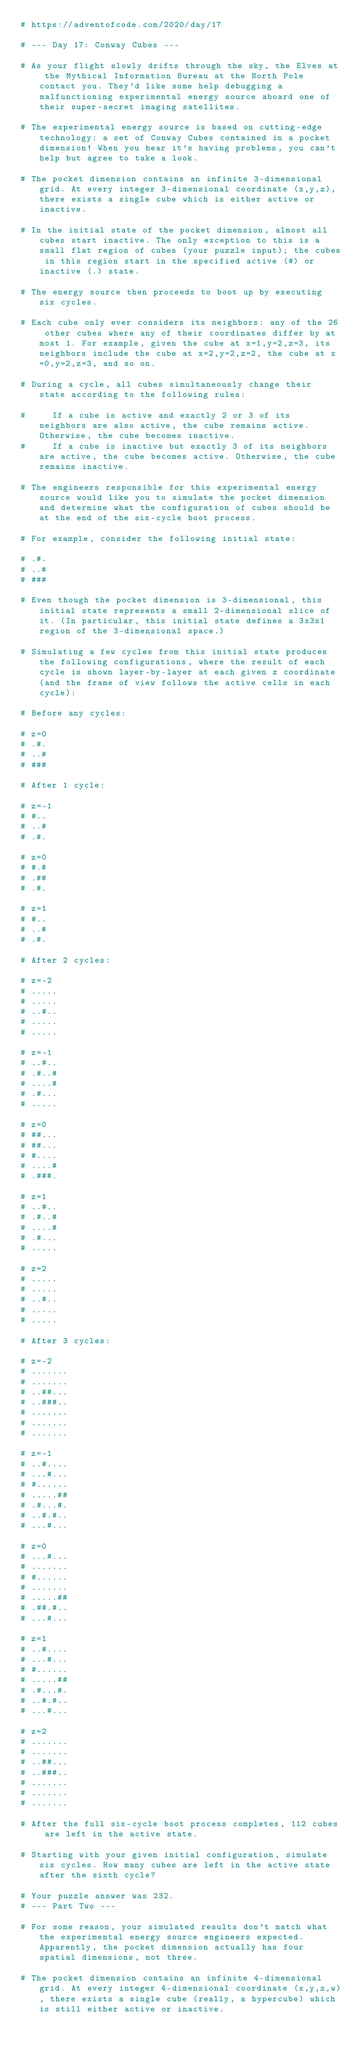<code> <loc_0><loc_0><loc_500><loc_500><_Crystal_># https://adventofcode.com/2020/day/17

# --- Day 17: Conway Cubes ---

# As your flight slowly drifts through the sky, the Elves at the Mythical Information Bureau at the North Pole contact you. They'd like some help debugging a malfunctioning experimental energy source aboard one of their super-secret imaging satellites.

# The experimental energy source is based on cutting-edge technology: a set of Conway Cubes contained in a pocket dimension! When you hear it's having problems, you can't help but agree to take a look.

# The pocket dimension contains an infinite 3-dimensional grid. At every integer 3-dimensional coordinate (x,y,z), there exists a single cube which is either active or inactive.

# In the initial state of the pocket dimension, almost all cubes start inactive. The only exception to this is a small flat region of cubes (your puzzle input); the cubes in this region start in the specified active (#) or inactive (.) state.

# The energy source then proceeds to boot up by executing six cycles.

# Each cube only ever considers its neighbors: any of the 26 other cubes where any of their coordinates differ by at most 1. For example, given the cube at x=1,y=2,z=3, its neighbors include the cube at x=2,y=2,z=2, the cube at x=0,y=2,z=3, and so on.

# During a cycle, all cubes simultaneously change their state according to the following rules:

#     If a cube is active and exactly 2 or 3 of its neighbors are also active, the cube remains active. Otherwise, the cube becomes inactive.
#     If a cube is inactive but exactly 3 of its neighbors are active, the cube becomes active. Otherwise, the cube remains inactive.

# The engineers responsible for this experimental energy source would like you to simulate the pocket dimension and determine what the configuration of cubes should be at the end of the six-cycle boot process.

# For example, consider the following initial state:

# .#.
# ..#
# ###

# Even though the pocket dimension is 3-dimensional, this initial state represents a small 2-dimensional slice of it. (In particular, this initial state defines a 3x3x1 region of the 3-dimensional space.)

# Simulating a few cycles from this initial state produces the following configurations, where the result of each cycle is shown layer-by-layer at each given z coordinate (and the frame of view follows the active cells in each cycle):

# Before any cycles:

# z=0
# .#.
# ..#
# ###

# After 1 cycle:

# z=-1
# #..
# ..#
# .#.

# z=0
# #.#
# .##
# .#.

# z=1
# #..
# ..#
# .#.

# After 2 cycles:

# z=-2
# .....
# .....
# ..#..
# .....
# .....

# z=-1
# ..#..
# .#..#
# ....#
# .#...
# .....

# z=0
# ##...
# ##...
# #....
# ....#
# .###.

# z=1
# ..#..
# .#..#
# ....#
# .#...
# .....

# z=2
# .....
# .....
# ..#..
# .....
# .....

# After 3 cycles:

# z=-2
# .......
# .......
# ..##...
# ..###..
# .......
# .......
# .......

# z=-1
# ..#....
# ...#...
# #......
# .....##
# .#...#.
# ..#.#..
# ...#...

# z=0
# ...#...
# .......
# #......
# .......
# .....##
# .##.#..
# ...#...

# z=1
# ..#....
# ...#...
# #......
# .....##
# .#...#.
# ..#.#..
# ...#...

# z=2
# .......
# .......
# ..##...
# ..###..
# .......
# .......
# .......

# After the full six-cycle boot process completes, 112 cubes are left in the active state.

# Starting with your given initial configuration, simulate six cycles. How many cubes are left in the active state after the sixth cycle?

# Your puzzle answer was 232.
# --- Part Two ---

# For some reason, your simulated results don't match what the experimental energy source engineers expected. Apparently, the pocket dimension actually has four spatial dimensions, not three.

# The pocket dimension contains an infinite 4-dimensional grid. At every integer 4-dimensional coordinate (x,y,z,w), there exists a single cube (really, a hypercube) which is still either active or inactive.
</code> 